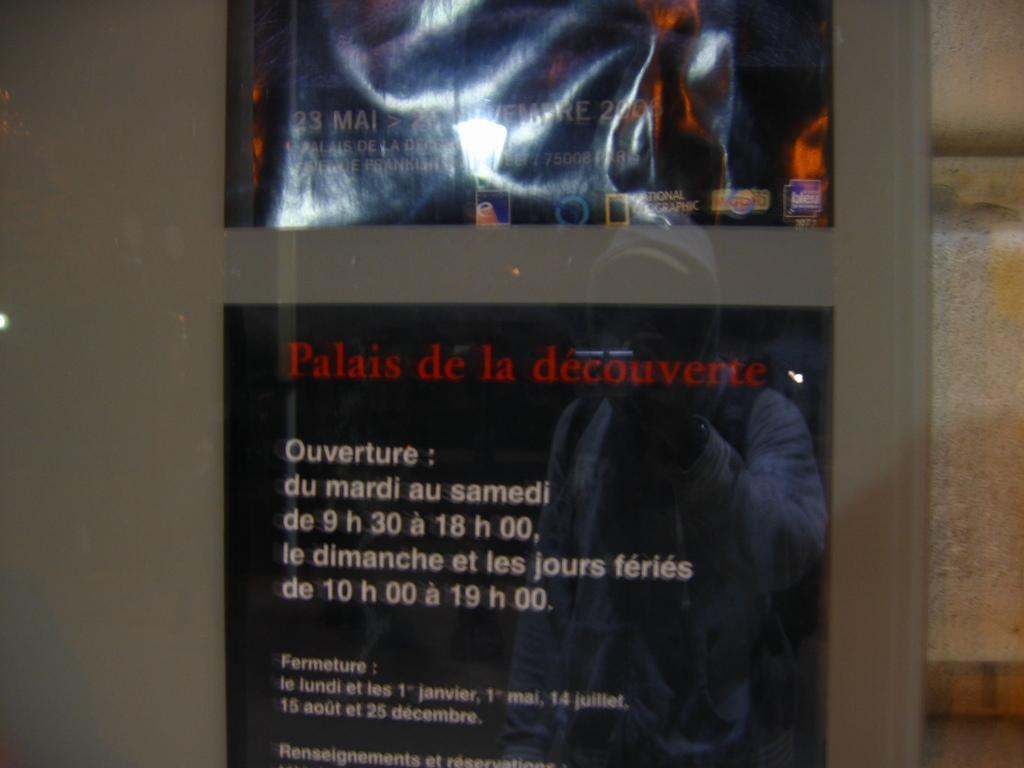How would you summarize this image in a sentence or two? In this image we can see a poster with some text on it, also we can see the wall, and reflection of a person on the glass. 